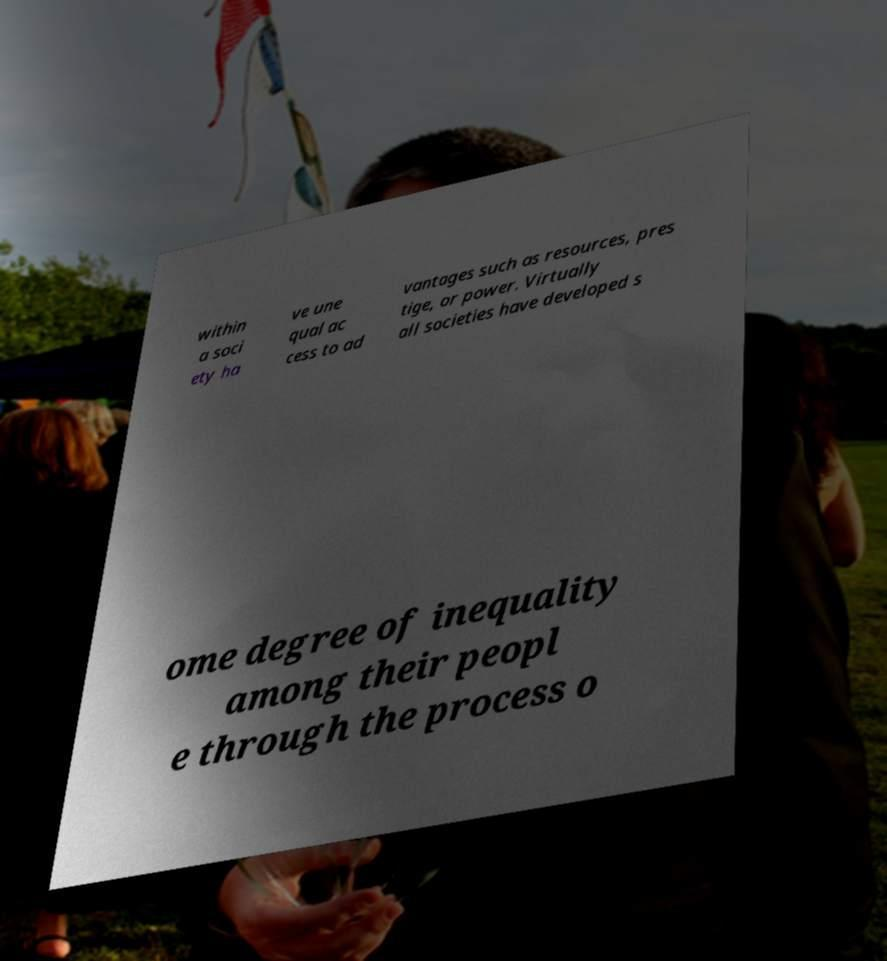Could you extract and type out the text from this image? within a soci ety ha ve une qual ac cess to ad vantages such as resources, pres tige, or power. Virtually all societies have developed s ome degree of inequality among their peopl e through the process o 